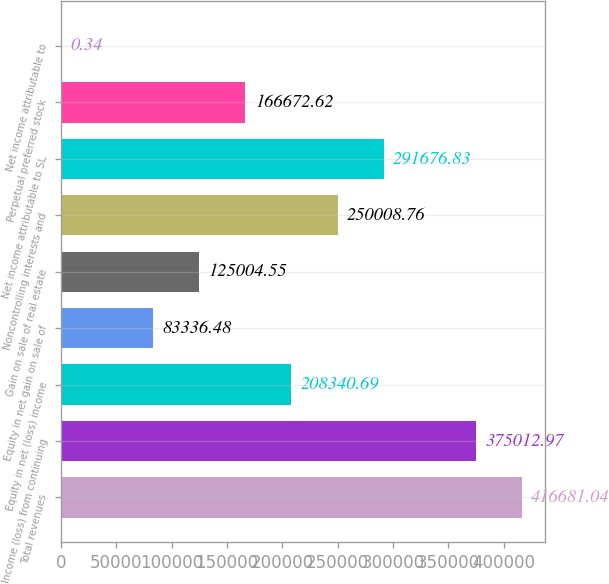Convert chart. <chart><loc_0><loc_0><loc_500><loc_500><bar_chart><fcel>Total revenues<fcel>Income (loss) from continuing<fcel>Equity in net (loss) income<fcel>Equity in net gain on sale of<fcel>Gain on sale of real estate<fcel>Noncontrolling interests and<fcel>Net income attributable to SL<fcel>Perpetual preferred stock<fcel>Net income attributable to<nl><fcel>416681<fcel>375013<fcel>208341<fcel>83336.5<fcel>125005<fcel>250009<fcel>291677<fcel>166673<fcel>0.34<nl></chart> 